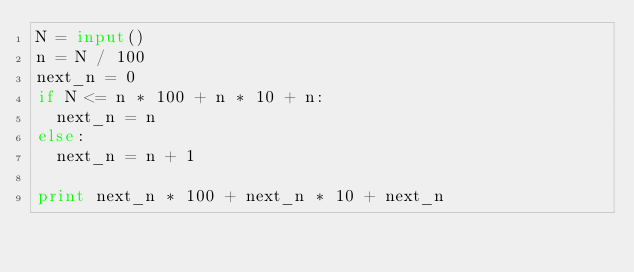<code> <loc_0><loc_0><loc_500><loc_500><_Python_>N = input()
n = N / 100
next_n = 0
if N <= n * 100 + n * 10 + n:
	next_n = n
else:
	next_n = n + 1

print next_n * 100 + next_n * 10 + next_n
</code> 